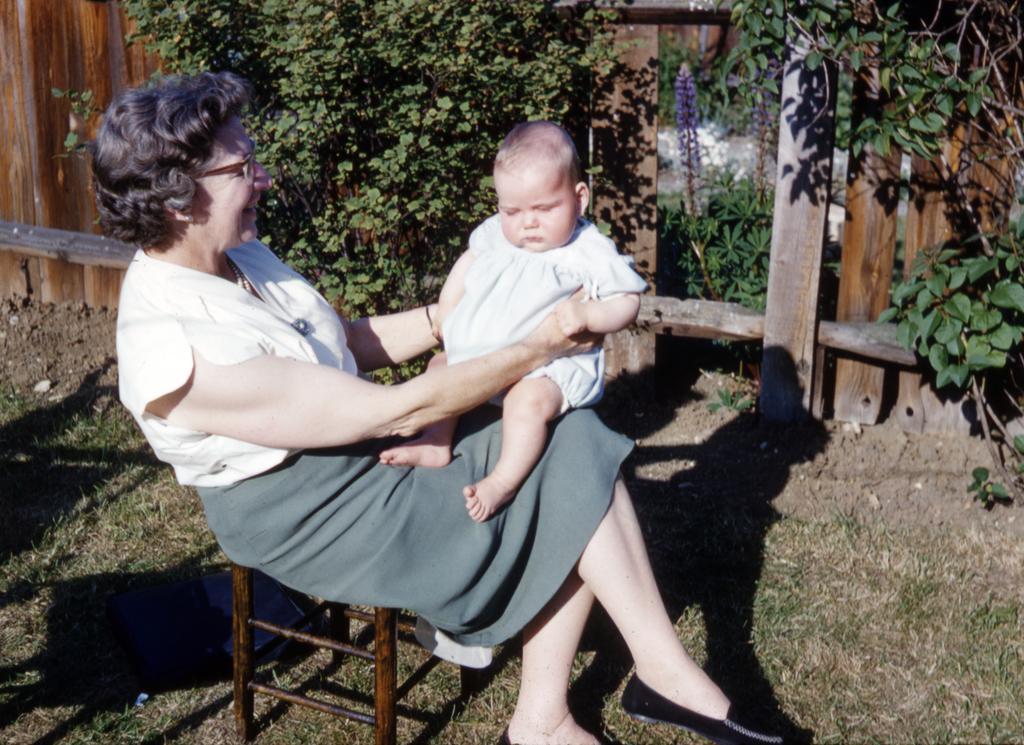How would you summarize this image in a sentence or two? In the middle of the image a woman is sitting on a chair and holding a baby. At the top of the image we can see some plants. Behind the plants we can see a fencing. At the bottom of the image we can see grass. 